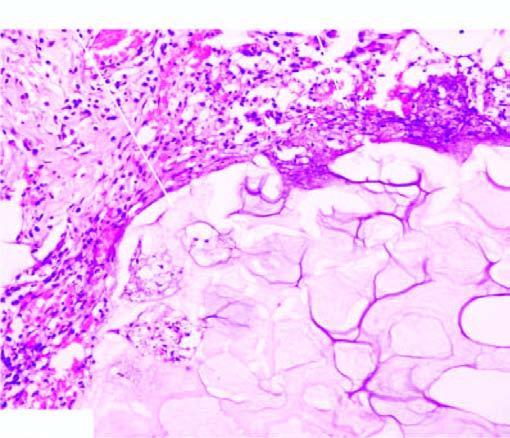s there cloudy appearance of adipocytes, coarse basophilic granular debris while the periphery shows a few mixed inflammatory cells?
Answer the question using a single word or phrase. Yes 